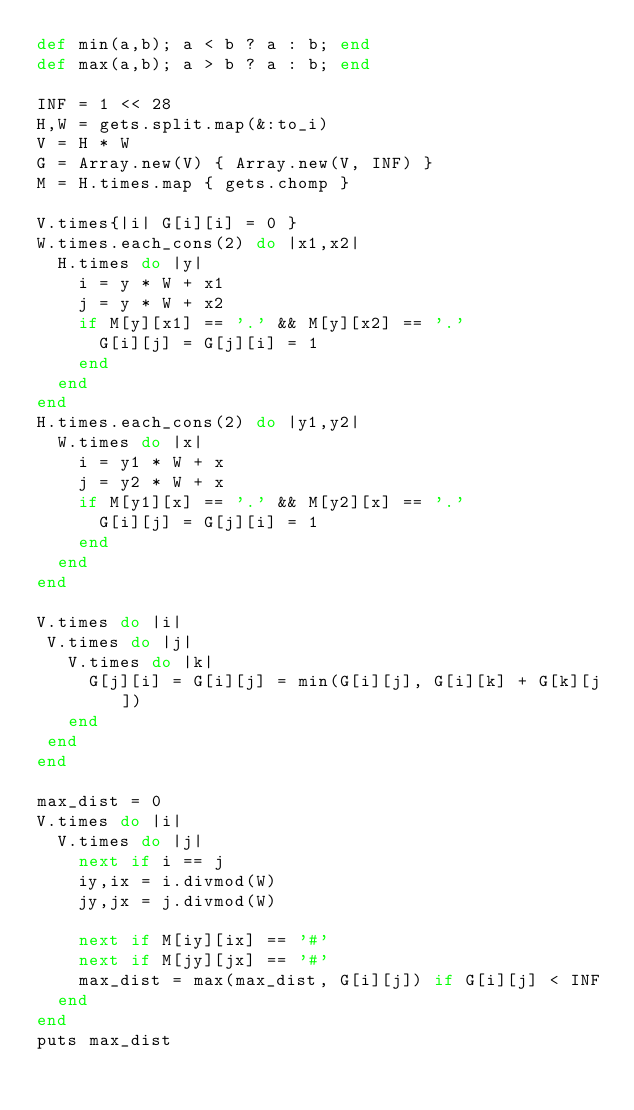Convert code to text. <code><loc_0><loc_0><loc_500><loc_500><_Ruby_>def min(a,b); a < b ? a : b; end
def max(a,b); a > b ? a : b; end

INF = 1 << 28
H,W = gets.split.map(&:to_i)
V = H * W
G = Array.new(V) { Array.new(V, INF) }
M = H.times.map { gets.chomp }

V.times{|i| G[i][i] = 0 }
W.times.each_cons(2) do |x1,x2|
  H.times do |y|
    i = y * W + x1
    j = y * W + x2
    if M[y][x1] == '.' && M[y][x2] == '.'
      G[i][j] = G[j][i] = 1
    end
  end
end
H.times.each_cons(2) do |y1,y2|
  W.times do |x|
    i = y1 * W + x
    j = y2 * W + x
    if M[y1][x] == '.' && M[y2][x] == '.'
      G[i][j] = G[j][i] = 1
    end
  end
end

V.times do |i|
 V.times do |j|
   V.times do |k|
     G[j][i] = G[i][j] = min(G[i][j], G[i][k] + G[k][j])
   end
 end
end

max_dist = 0
V.times do |i|
  V.times do |j|
    next if i == j
    iy,ix = i.divmod(W)
    jy,jx = j.divmod(W)
    
    next if M[iy][ix] == '#'
    next if M[jy][jx] == '#'
    max_dist = max(max_dist, G[i][j]) if G[i][j] < INF
  end
end
puts max_dist
</code> 